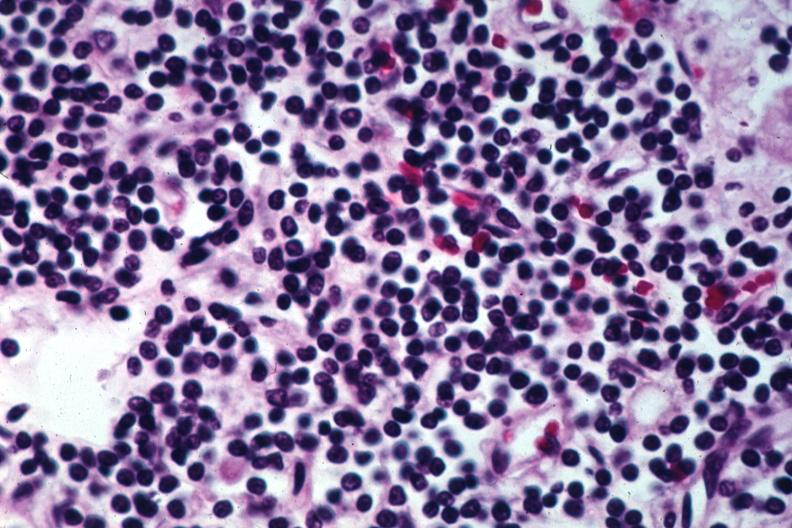does good example either chest show pleomorphic small lymphocytes?
Answer the question using a single word or phrase. No 